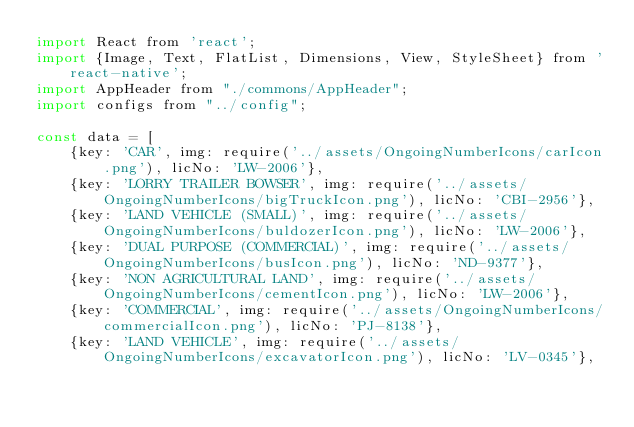Convert code to text. <code><loc_0><loc_0><loc_500><loc_500><_JavaScript_>import React from 'react';
import {Image, Text, FlatList, Dimensions, View, StyleSheet} from 'react-native';
import AppHeader from "./commons/AppHeader";
import configs from "../config";

const data = [
    {key: 'CAR', img: require('../assets/OngoingNumberIcons/carIcon.png'), licNo: 'LW-2006'},
    {key: 'LORRY TRAILER BOWSER', img: require('../assets/OngoingNumberIcons/bigTruckIcon.png'), licNo: 'CBI-2956'},
    {key: 'LAND VEHICLE (SMALL)', img: require('../assets/OngoingNumberIcons/buldozerIcon.png'), licNo: 'LW-2006'},
    {key: 'DUAL PURPOSE (COMMERCIAL)', img: require('../assets/OngoingNumberIcons/busIcon.png'), licNo: 'ND-9377'},
    {key: 'NON AGRICULTURAL LAND', img: require('../assets/OngoingNumberIcons/cementIcon.png'), licNo: 'LW-2006'},
    {key: 'COMMERCIAL', img: require('../assets/OngoingNumberIcons/commercialIcon.png'), licNo: 'PJ-8138'},
    {key: 'LAND VEHICLE', img: require('../assets/OngoingNumberIcons/excavatorIcon.png'), licNo: 'LV-0345'},</code> 